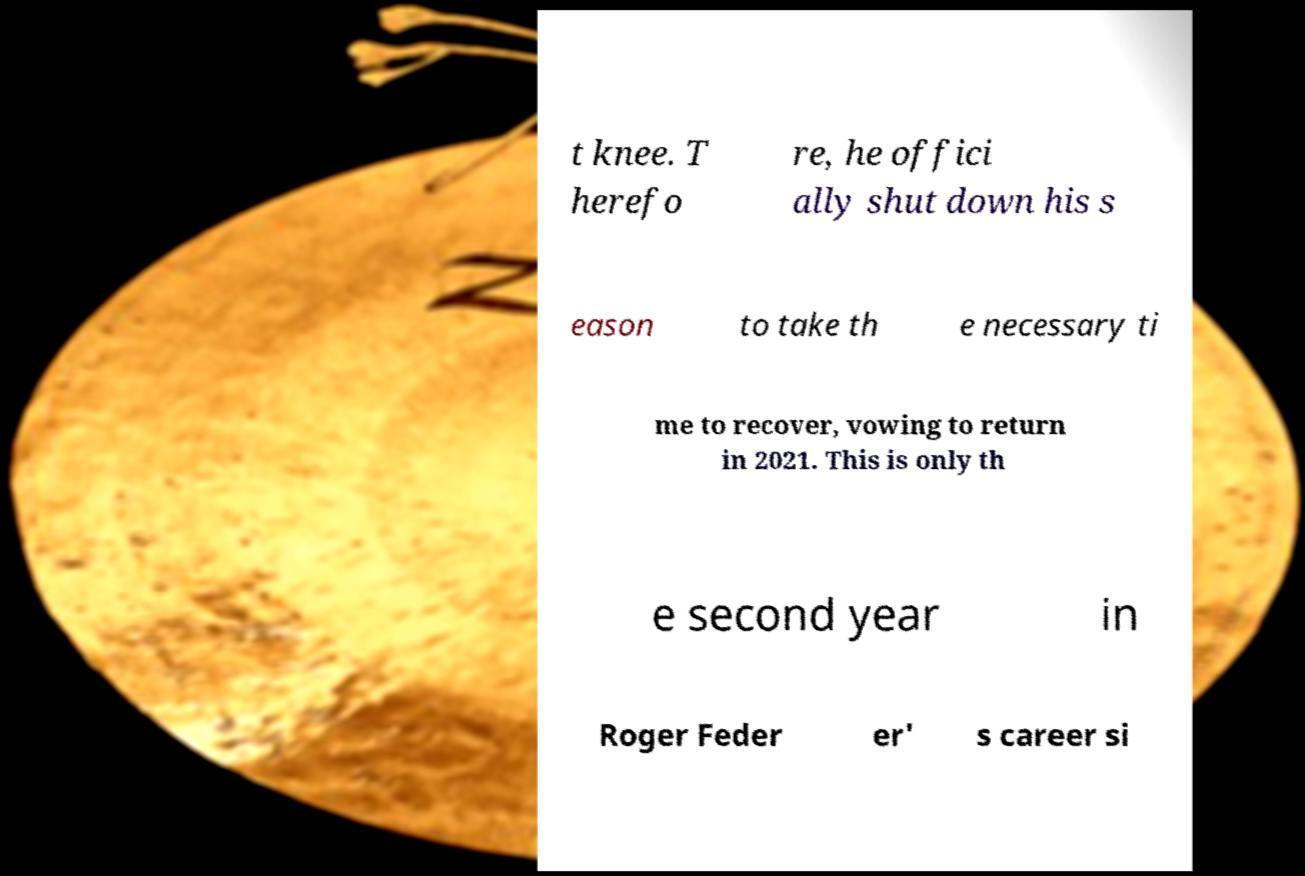What messages or text are displayed in this image? I need them in a readable, typed format. t knee. T herefo re, he offici ally shut down his s eason to take th e necessary ti me to recover, vowing to return in 2021. This is only th e second year in Roger Feder er' s career si 